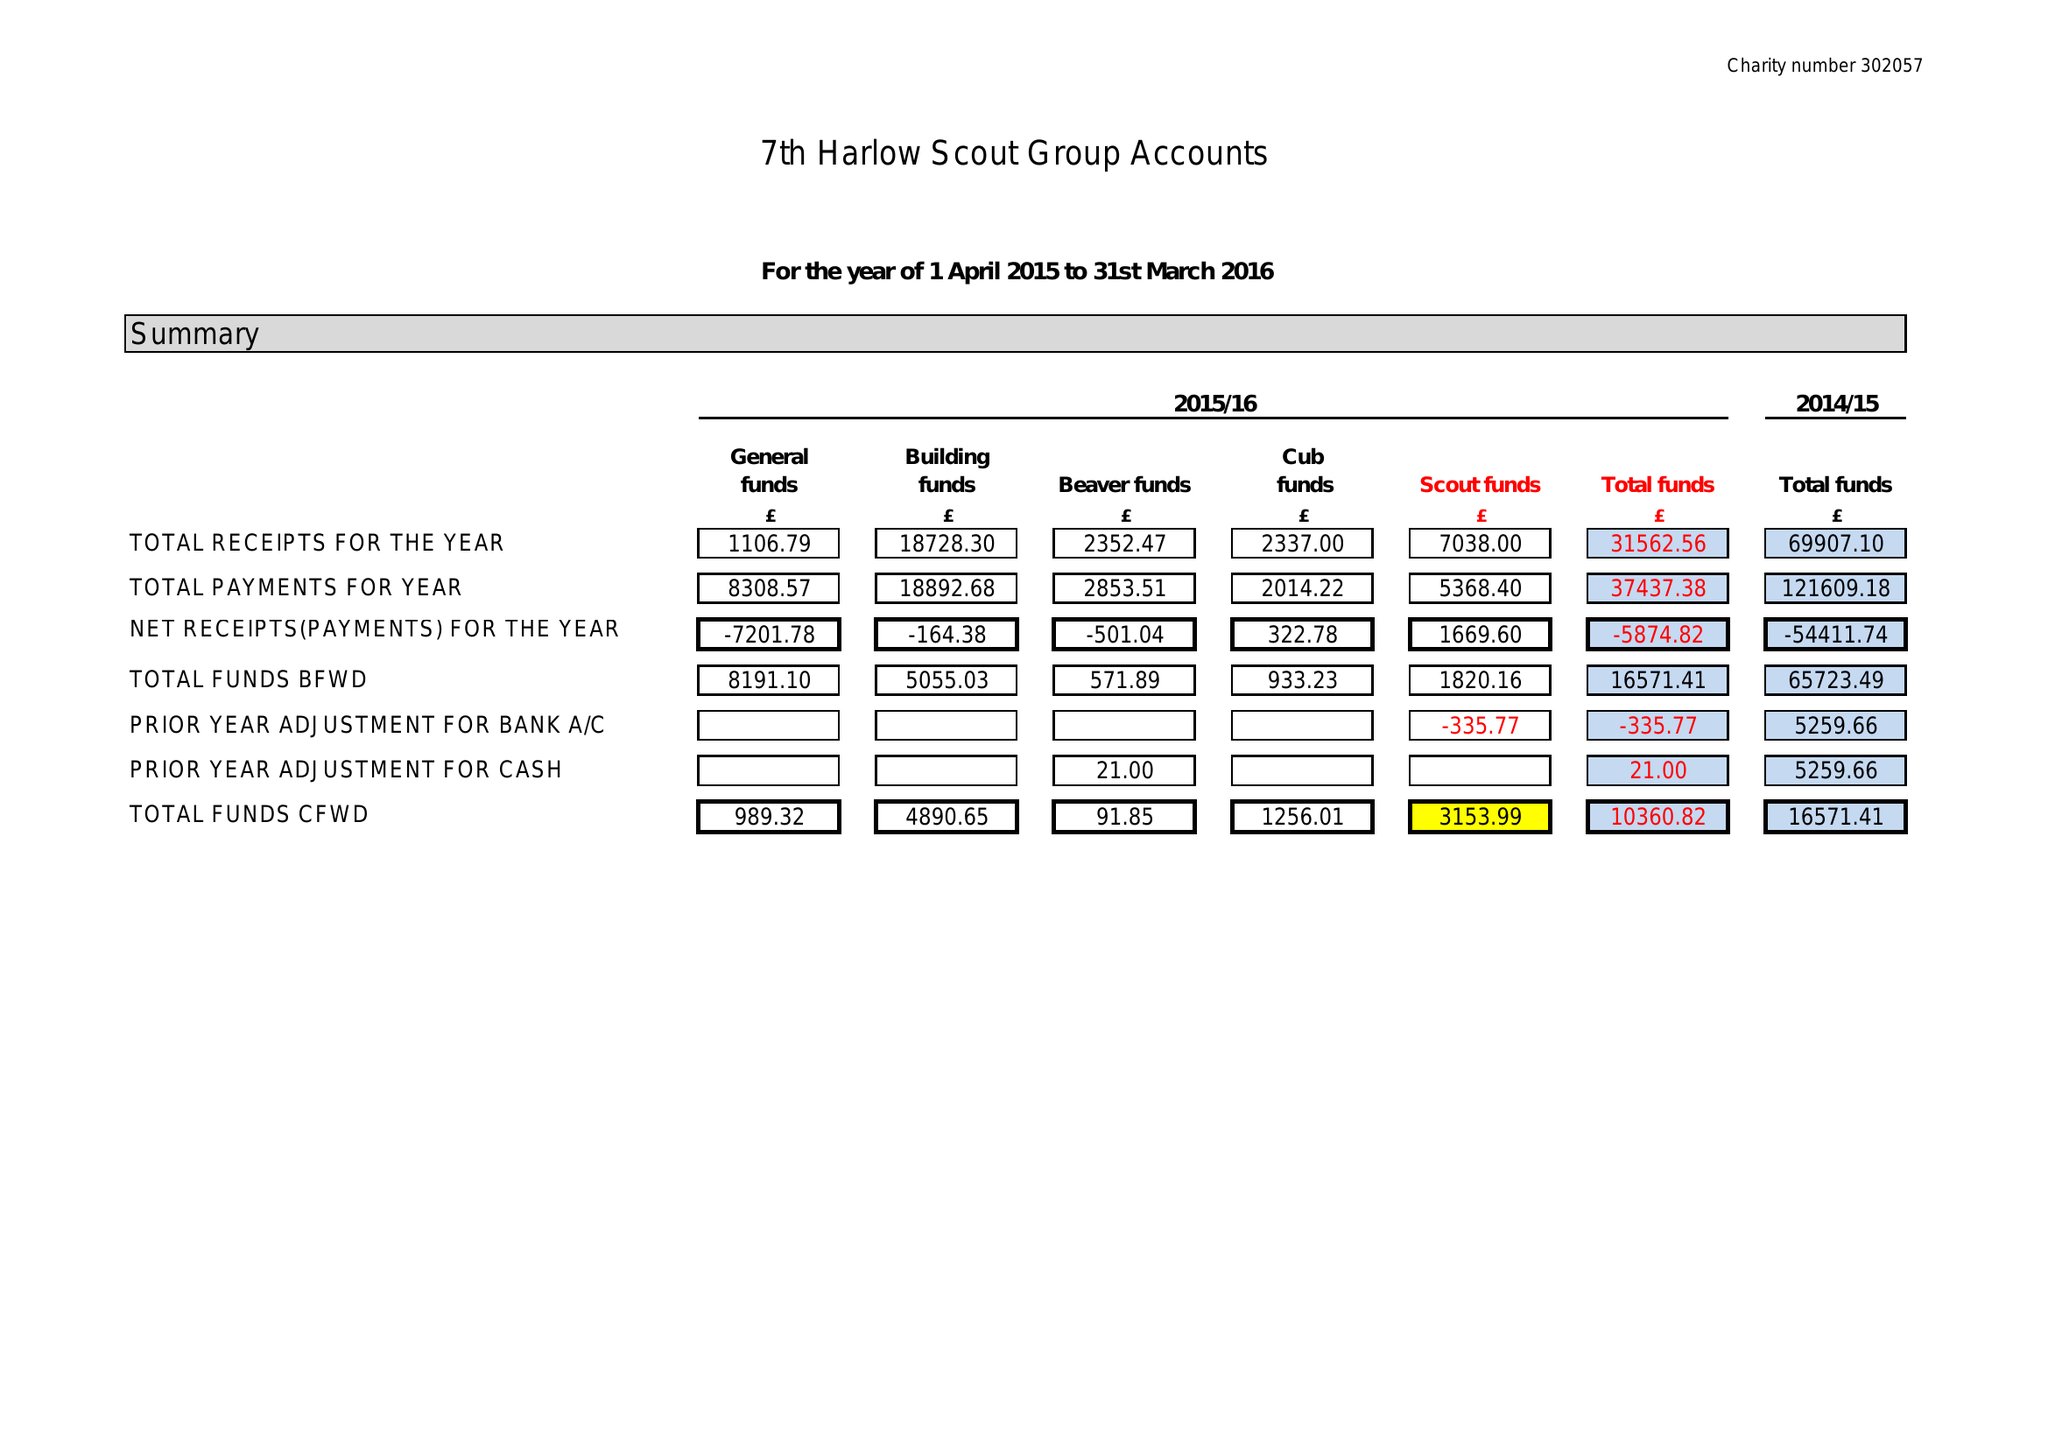What is the value for the report_date?
Answer the question using a single word or phrase. 2016-03-31 